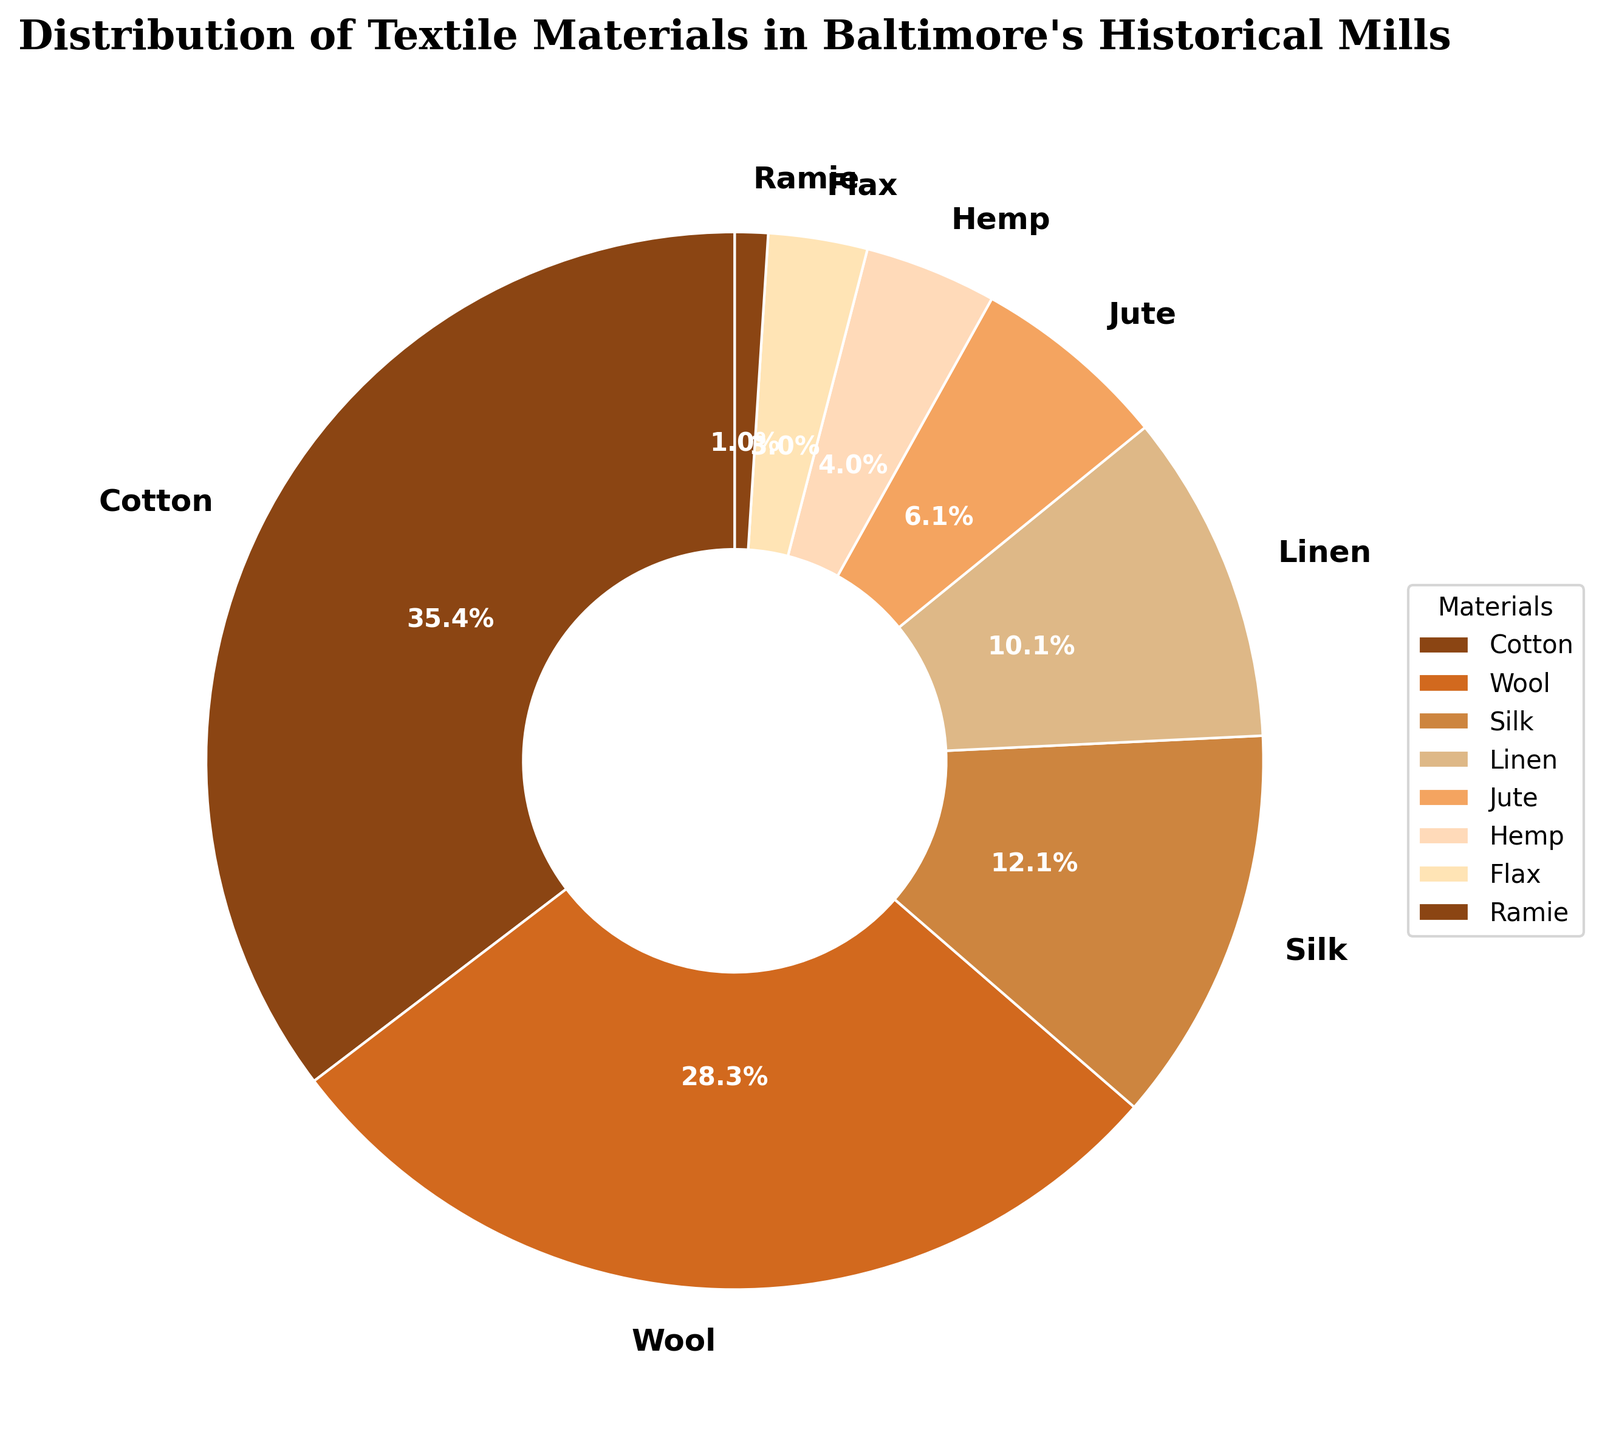What is the most commonly used textile material in Baltimore's historical mills? From the pie chart, the largest segment corresponds to Cotton, which has the highest percentage of 35%.
Answer: Cotton What percentage of textile materials used in Baltimore's historical mills are made up of Silk? The pie chart specifically shows that Silk makes up 12% of the total textile materials.
Answer: 12% How much larger is the percentage of Cotton than Linen? Cotton accounts for 35%, while Linen accounts for 10%. The difference is 35% - 10% = 25%.
Answer: 25% What is the combined percentage of Jute and Hemp in the pie chart? Jute accounts for 6% and Hemp accounts for 4%. The combined percentage is 6% + 4% = 10%.
Answer: 10% Which two materials have the closest percentages? Wool has 28% and Silk has 12%. Comparing other materials, Linen has 10%, closer to Silk's 12%. Therefore, Wool and Silk are the closest to each other in percentages.
Answer: Linen and Silk Is Silk used more frequently than Linen in Baltimore's historical mills? Silk accounts for 12% while Linen accounts for 10%, thus Silk is used more frequently than Linen.
Answer: Yes What is the total percentage of Cotton, Wool, and Silk combined? Cotton is 35%, Wool is 28%, and Silk is 12%. Adding these together: 35% + 28% + 12% = 75%.
Answer: 75% What fraction of the pie chart does Wool occupy? Wool has a percentage of 28%. To convert this into fraction: 28/100 = 7/25. So, Wool occupies 7/25 of the pie chart.
Answer: 7/25 By how much does the percentage of Cotton exceed the sum of Flax and Ramie? Cotton makes up 35%, Flax is 3%, and Ramie is 1%. Summing Flax and Ramie: 3% + 1% = 4%. The difference is 35% - 4% = 31%.
Answer: 31% What are the percentages of the textile materials that are explicitly labeled in the pie chart? The materials labeled are Cotton (35%), Wool (28%), Silk (12%), Linen (10%), Jute (6%), Hemp (4%), Flax (3%), and Ramie (1%) because materials below 1% are not labeled. Summed together: 35% + 28% + 12% + 10% + 6% + 4% + 3% + 1% = 99%.
Answer: 99% 